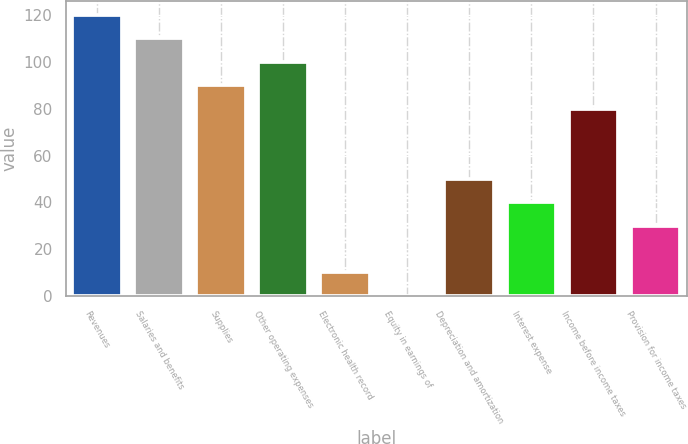Convert chart to OTSL. <chart><loc_0><loc_0><loc_500><loc_500><bar_chart><fcel>Revenues<fcel>Salaries and benefits<fcel>Supplies<fcel>Other operating expenses<fcel>Electronic health record<fcel>Equity in earnings of<fcel>Depreciation and amortization<fcel>Interest expense<fcel>Income before income taxes<fcel>Provision for income taxes<nl><fcel>119.98<fcel>109.99<fcel>90.01<fcel>100<fcel>10.09<fcel>0.1<fcel>50.05<fcel>40.06<fcel>80.02<fcel>30.07<nl></chart> 